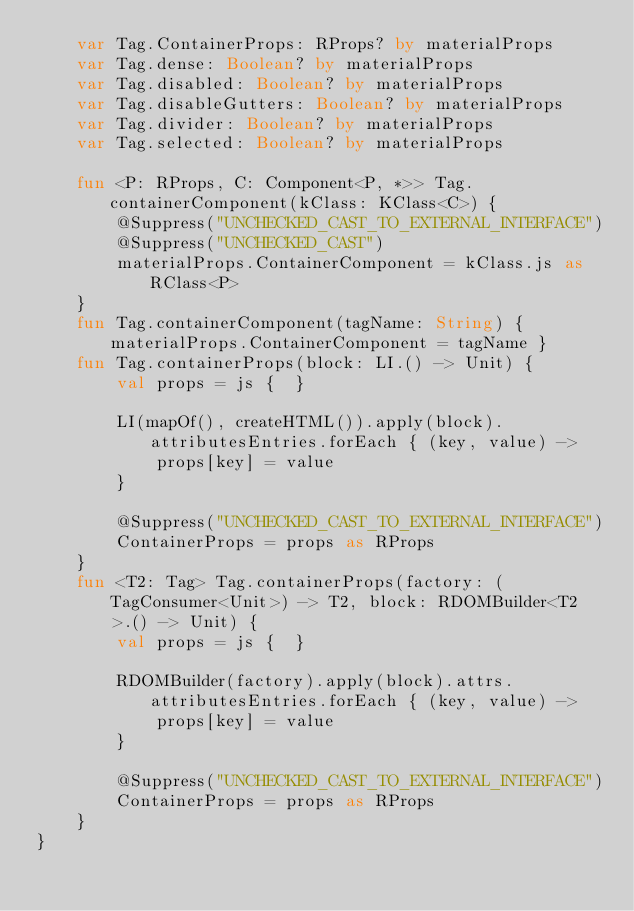<code> <loc_0><loc_0><loc_500><loc_500><_Kotlin_>    var Tag.ContainerProps: RProps? by materialProps
    var Tag.dense: Boolean? by materialProps
    var Tag.disabled: Boolean? by materialProps
    var Tag.disableGutters: Boolean? by materialProps
    var Tag.divider: Boolean? by materialProps
    var Tag.selected: Boolean? by materialProps

    fun <P: RProps, C: Component<P, *>> Tag.containerComponent(kClass: KClass<C>) {
        @Suppress("UNCHECKED_CAST_TO_EXTERNAL_INTERFACE")
        @Suppress("UNCHECKED_CAST")
        materialProps.ContainerComponent = kClass.js as RClass<P>
    }
    fun Tag.containerComponent(tagName: String) { materialProps.ContainerComponent = tagName }
    fun Tag.containerProps(block: LI.() -> Unit) {
        val props = js {  }

        LI(mapOf(), createHTML()).apply(block).attributesEntries.forEach { (key, value) ->
            props[key] = value
        }

        @Suppress("UNCHECKED_CAST_TO_EXTERNAL_INTERFACE")
        ContainerProps = props as RProps
    }
    fun <T2: Tag> Tag.containerProps(factory: (TagConsumer<Unit>) -> T2, block: RDOMBuilder<T2>.() -> Unit) {
        val props = js {  }

        RDOMBuilder(factory).apply(block).attrs.attributesEntries.forEach { (key, value) ->
            props[key] = value
        }

        @Suppress("UNCHECKED_CAST_TO_EXTERNAL_INTERFACE")
        ContainerProps = props as RProps
    }
}</code> 